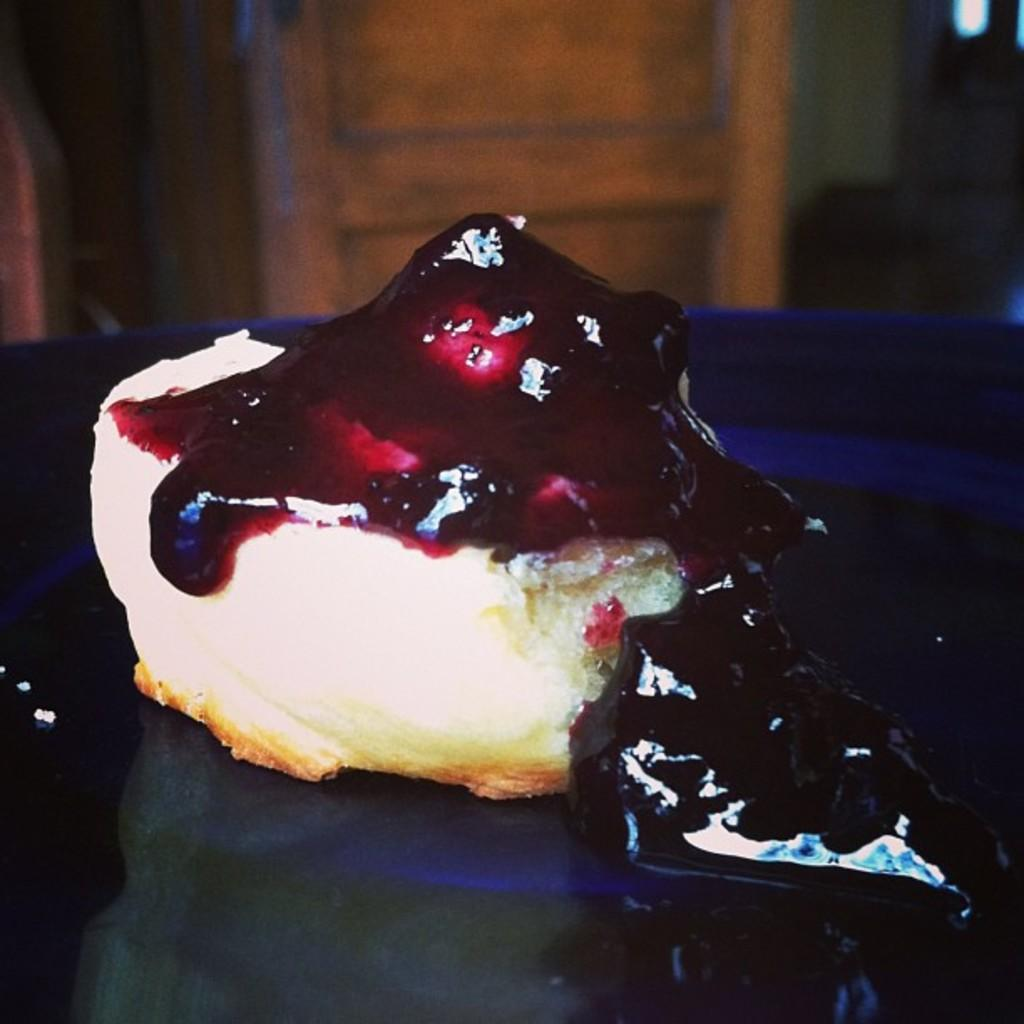What is on the plate that is visible in the image? There is food on the plate in the image. What can be seen in the background of the image? There is a wooden door and a wall in the background of the image. Are there any other objects visible in the background? Yes, there are objects visible in the background of the image. What type of skin is visible on the food in the image? There is no skin visible in the image, as the main subject is the plate with food on it. 